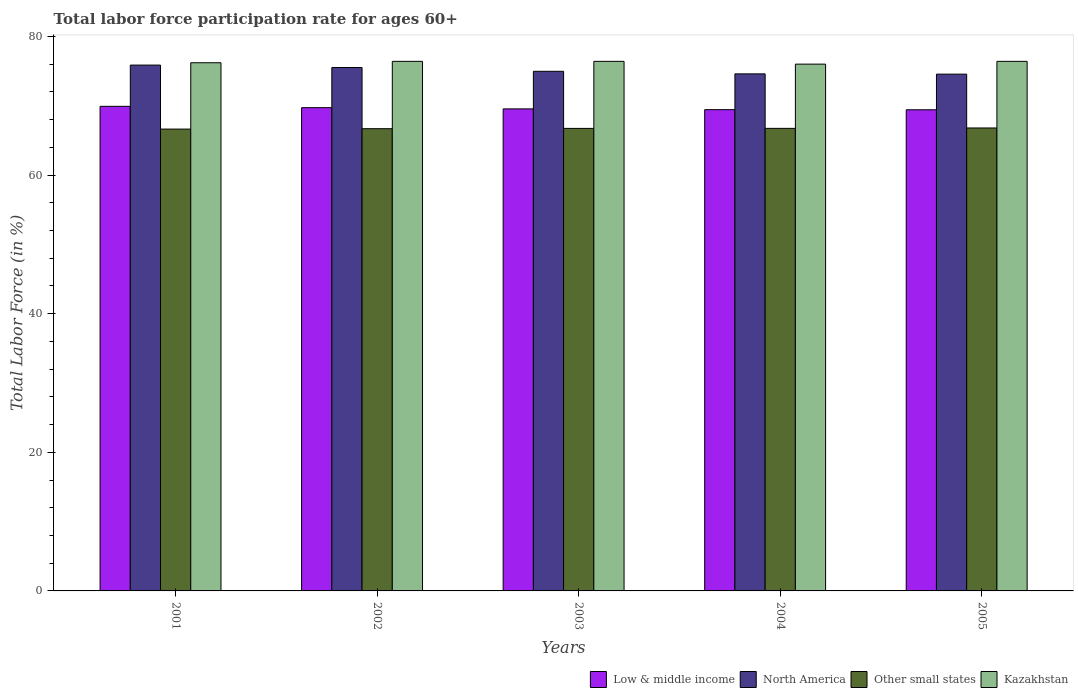How many different coloured bars are there?
Offer a very short reply. 4. How many groups of bars are there?
Offer a very short reply. 5. Are the number of bars per tick equal to the number of legend labels?
Provide a succinct answer. Yes. How many bars are there on the 5th tick from the left?
Give a very brief answer. 4. How many bars are there on the 3rd tick from the right?
Make the answer very short. 4. What is the labor force participation rate in Kazakhstan in 2001?
Offer a terse response. 76.2. Across all years, what is the maximum labor force participation rate in Low & middle income?
Ensure brevity in your answer.  69.91. Across all years, what is the minimum labor force participation rate in North America?
Your answer should be compact. 74.55. In which year was the labor force participation rate in North America maximum?
Provide a short and direct response. 2001. In which year was the labor force participation rate in Kazakhstan minimum?
Offer a very short reply. 2004. What is the total labor force participation rate in North America in the graph?
Keep it short and to the point. 375.48. What is the difference between the labor force participation rate in North America in 2004 and that in 2005?
Your answer should be compact. 0.04. What is the difference between the labor force participation rate in Kazakhstan in 2003 and the labor force participation rate in Other small states in 2001?
Give a very brief answer. 9.77. What is the average labor force participation rate in Other small states per year?
Your answer should be very brief. 66.71. In the year 2004, what is the difference between the labor force participation rate in North America and labor force participation rate in Kazakhstan?
Your response must be concise. -1.41. In how many years, is the labor force participation rate in Low & middle income greater than 44 %?
Make the answer very short. 5. What is the ratio of the labor force participation rate in Kazakhstan in 2001 to that in 2004?
Your answer should be compact. 1. What is the difference between the highest and the lowest labor force participation rate in Other small states?
Provide a succinct answer. 0.16. Is the sum of the labor force participation rate in Kazakhstan in 2001 and 2003 greater than the maximum labor force participation rate in Other small states across all years?
Give a very brief answer. Yes. What does the 4th bar from the right in 2001 represents?
Your answer should be very brief. Low & middle income. Is it the case that in every year, the sum of the labor force participation rate in North America and labor force participation rate in Kazakhstan is greater than the labor force participation rate in Other small states?
Offer a very short reply. Yes. Are all the bars in the graph horizontal?
Keep it short and to the point. No. How many years are there in the graph?
Make the answer very short. 5. What is the difference between two consecutive major ticks on the Y-axis?
Give a very brief answer. 20. Where does the legend appear in the graph?
Offer a terse response. Bottom right. How are the legend labels stacked?
Provide a short and direct response. Horizontal. What is the title of the graph?
Offer a very short reply. Total labor force participation rate for ages 60+. What is the label or title of the X-axis?
Provide a succinct answer. Years. What is the label or title of the Y-axis?
Your response must be concise. Total Labor Force (in %). What is the Total Labor Force (in %) of Low & middle income in 2001?
Ensure brevity in your answer.  69.91. What is the Total Labor Force (in %) in North America in 2001?
Keep it short and to the point. 75.86. What is the Total Labor Force (in %) in Other small states in 2001?
Your answer should be compact. 66.63. What is the Total Labor Force (in %) of Kazakhstan in 2001?
Offer a terse response. 76.2. What is the Total Labor Force (in %) of Low & middle income in 2002?
Your response must be concise. 69.72. What is the Total Labor Force (in %) of North America in 2002?
Make the answer very short. 75.51. What is the Total Labor Force (in %) in Other small states in 2002?
Ensure brevity in your answer.  66.69. What is the Total Labor Force (in %) in Kazakhstan in 2002?
Your response must be concise. 76.4. What is the Total Labor Force (in %) of Low & middle income in 2003?
Provide a succinct answer. 69.54. What is the Total Labor Force (in %) in North America in 2003?
Your answer should be very brief. 74.96. What is the Total Labor Force (in %) in Other small states in 2003?
Keep it short and to the point. 66.73. What is the Total Labor Force (in %) in Kazakhstan in 2003?
Keep it short and to the point. 76.4. What is the Total Labor Force (in %) of Low & middle income in 2004?
Offer a terse response. 69.43. What is the Total Labor Force (in %) in North America in 2004?
Offer a very short reply. 74.59. What is the Total Labor Force (in %) in Other small states in 2004?
Your response must be concise. 66.73. What is the Total Labor Force (in %) in Kazakhstan in 2004?
Your response must be concise. 76. What is the Total Labor Force (in %) of Low & middle income in 2005?
Keep it short and to the point. 69.41. What is the Total Labor Force (in %) of North America in 2005?
Your answer should be very brief. 74.55. What is the Total Labor Force (in %) in Other small states in 2005?
Provide a succinct answer. 66.79. What is the Total Labor Force (in %) of Kazakhstan in 2005?
Offer a terse response. 76.4. Across all years, what is the maximum Total Labor Force (in %) of Low & middle income?
Make the answer very short. 69.91. Across all years, what is the maximum Total Labor Force (in %) in North America?
Ensure brevity in your answer.  75.86. Across all years, what is the maximum Total Labor Force (in %) of Other small states?
Provide a short and direct response. 66.79. Across all years, what is the maximum Total Labor Force (in %) in Kazakhstan?
Ensure brevity in your answer.  76.4. Across all years, what is the minimum Total Labor Force (in %) of Low & middle income?
Offer a terse response. 69.41. Across all years, what is the minimum Total Labor Force (in %) in North America?
Make the answer very short. 74.55. Across all years, what is the minimum Total Labor Force (in %) of Other small states?
Your answer should be compact. 66.63. What is the total Total Labor Force (in %) in Low & middle income in the graph?
Your response must be concise. 348.01. What is the total Total Labor Force (in %) in North America in the graph?
Your response must be concise. 375.48. What is the total Total Labor Force (in %) of Other small states in the graph?
Your answer should be compact. 333.56. What is the total Total Labor Force (in %) in Kazakhstan in the graph?
Give a very brief answer. 381.4. What is the difference between the Total Labor Force (in %) in Low & middle income in 2001 and that in 2002?
Offer a terse response. 0.19. What is the difference between the Total Labor Force (in %) of North America in 2001 and that in 2002?
Make the answer very short. 0.35. What is the difference between the Total Labor Force (in %) in Other small states in 2001 and that in 2002?
Make the answer very short. -0.06. What is the difference between the Total Labor Force (in %) in Low & middle income in 2001 and that in 2003?
Make the answer very short. 0.37. What is the difference between the Total Labor Force (in %) in North America in 2001 and that in 2003?
Offer a very short reply. 0.9. What is the difference between the Total Labor Force (in %) in Other small states in 2001 and that in 2003?
Provide a short and direct response. -0.1. What is the difference between the Total Labor Force (in %) in Kazakhstan in 2001 and that in 2003?
Give a very brief answer. -0.2. What is the difference between the Total Labor Force (in %) of Low & middle income in 2001 and that in 2004?
Ensure brevity in your answer.  0.48. What is the difference between the Total Labor Force (in %) in North America in 2001 and that in 2004?
Ensure brevity in your answer.  1.27. What is the difference between the Total Labor Force (in %) in Other small states in 2001 and that in 2004?
Your answer should be very brief. -0.1. What is the difference between the Total Labor Force (in %) in Kazakhstan in 2001 and that in 2004?
Give a very brief answer. 0.2. What is the difference between the Total Labor Force (in %) in Low & middle income in 2001 and that in 2005?
Provide a succinct answer. 0.5. What is the difference between the Total Labor Force (in %) of North America in 2001 and that in 2005?
Provide a short and direct response. 1.31. What is the difference between the Total Labor Force (in %) of Other small states in 2001 and that in 2005?
Offer a very short reply. -0.16. What is the difference between the Total Labor Force (in %) of Kazakhstan in 2001 and that in 2005?
Offer a terse response. -0.2. What is the difference between the Total Labor Force (in %) in Low & middle income in 2002 and that in 2003?
Your response must be concise. 0.18. What is the difference between the Total Labor Force (in %) in North America in 2002 and that in 2003?
Make the answer very short. 0.55. What is the difference between the Total Labor Force (in %) in Other small states in 2002 and that in 2003?
Provide a short and direct response. -0.04. What is the difference between the Total Labor Force (in %) in Low & middle income in 2002 and that in 2004?
Ensure brevity in your answer.  0.29. What is the difference between the Total Labor Force (in %) in North America in 2002 and that in 2004?
Make the answer very short. 0.92. What is the difference between the Total Labor Force (in %) in Other small states in 2002 and that in 2004?
Make the answer very short. -0.05. What is the difference between the Total Labor Force (in %) of Kazakhstan in 2002 and that in 2004?
Offer a terse response. 0.4. What is the difference between the Total Labor Force (in %) of Low & middle income in 2002 and that in 2005?
Ensure brevity in your answer.  0.31. What is the difference between the Total Labor Force (in %) of North America in 2002 and that in 2005?
Keep it short and to the point. 0.96. What is the difference between the Total Labor Force (in %) in Other small states in 2002 and that in 2005?
Your response must be concise. -0.1. What is the difference between the Total Labor Force (in %) in Low & middle income in 2003 and that in 2004?
Give a very brief answer. 0.11. What is the difference between the Total Labor Force (in %) of North America in 2003 and that in 2004?
Your response must be concise. 0.37. What is the difference between the Total Labor Force (in %) of Other small states in 2003 and that in 2004?
Keep it short and to the point. -0. What is the difference between the Total Labor Force (in %) in Kazakhstan in 2003 and that in 2004?
Keep it short and to the point. 0.4. What is the difference between the Total Labor Force (in %) of Low & middle income in 2003 and that in 2005?
Offer a very short reply. 0.13. What is the difference between the Total Labor Force (in %) of North America in 2003 and that in 2005?
Ensure brevity in your answer.  0.41. What is the difference between the Total Labor Force (in %) in Other small states in 2003 and that in 2005?
Your answer should be very brief. -0.06. What is the difference between the Total Labor Force (in %) in Kazakhstan in 2003 and that in 2005?
Give a very brief answer. 0. What is the difference between the Total Labor Force (in %) in Low & middle income in 2004 and that in 2005?
Provide a short and direct response. 0.02. What is the difference between the Total Labor Force (in %) of North America in 2004 and that in 2005?
Keep it short and to the point. 0.04. What is the difference between the Total Labor Force (in %) of Other small states in 2004 and that in 2005?
Offer a terse response. -0.06. What is the difference between the Total Labor Force (in %) in Kazakhstan in 2004 and that in 2005?
Your response must be concise. -0.4. What is the difference between the Total Labor Force (in %) of Low & middle income in 2001 and the Total Labor Force (in %) of North America in 2002?
Your response must be concise. -5.6. What is the difference between the Total Labor Force (in %) in Low & middle income in 2001 and the Total Labor Force (in %) in Other small states in 2002?
Your answer should be compact. 3.22. What is the difference between the Total Labor Force (in %) of Low & middle income in 2001 and the Total Labor Force (in %) of Kazakhstan in 2002?
Your answer should be compact. -6.49. What is the difference between the Total Labor Force (in %) in North America in 2001 and the Total Labor Force (in %) in Other small states in 2002?
Keep it short and to the point. 9.18. What is the difference between the Total Labor Force (in %) of North America in 2001 and the Total Labor Force (in %) of Kazakhstan in 2002?
Provide a short and direct response. -0.54. What is the difference between the Total Labor Force (in %) in Other small states in 2001 and the Total Labor Force (in %) in Kazakhstan in 2002?
Your answer should be compact. -9.77. What is the difference between the Total Labor Force (in %) in Low & middle income in 2001 and the Total Labor Force (in %) in North America in 2003?
Your response must be concise. -5.05. What is the difference between the Total Labor Force (in %) in Low & middle income in 2001 and the Total Labor Force (in %) in Other small states in 2003?
Provide a succinct answer. 3.18. What is the difference between the Total Labor Force (in %) of Low & middle income in 2001 and the Total Labor Force (in %) of Kazakhstan in 2003?
Keep it short and to the point. -6.49. What is the difference between the Total Labor Force (in %) of North America in 2001 and the Total Labor Force (in %) of Other small states in 2003?
Offer a very short reply. 9.13. What is the difference between the Total Labor Force (in %) in North America in 2001 and the Total Labor Force (in %) in Kazakhstan in 2003?
Your answer should be very brief. -0.54. What is the difference between the Total Labor Force (in %) of Other small states in 2001 and the Total Labor Force (in %) of Kazakhstan in 2003?
Make the answer very short. -9.77. What is the difference between the Total Labor Force (in %) of Low & middle income in 2001 and the Total Labor Force (in %) of North America in 2004?
Provide a succinct answer. -4.68. What is the difference between the Total Labor Force (in %) of Low & middle income in 2001 and the Total Labor Force (in %) of Other small states in 2004?
Your answer should be very brief. 3.18. What is the difference between the Total Labor Force (in %) in Low & middle income in 2001 and the Total Labor Force (in %) in Kazakhstan in 2004?
Give a very brief answer. -6.09. What is the difference between the Total Labor Force (in %) in North America in 2001 and the Total Labor Force (in %) in Other small states in 2004?
Keep it short and to the point. 9.13. What is the difference between the Total Labor Force (in %) in North America in 2001 and the Total Labor Force (in %) in Kazakhstan in 2004?
Ensure brevity in your answer.  -0.14. What is the difference between the Total Labor Force (in %) of Other small states in 2001 and the Total Labor Force (in %) of Kazakhstan in 2004?
Your response must be concise. -9.37. What is the difference between the Total Labor Force (in %) of Low & middle income in 2001 and the Total Labor Force (in %) of North America in 2005?
Ensure brevity in your answer.  -4.64. What is the difference between the Total Labor Force (in %) of Low & middle income in 2001 and the Total Labor Force (in %) of Other small states in 2005?
Offer a very short reply. 3.12. What is the difference between the Total Labor Force (in %) of Low & middle income in 2001 and the Total Labor Force (in %) of Kazakhstan in 2005?
Keep it short and to the point. -6.49. What is the difference between the Total Labor Force (in %) of North America in 2001 and the Total Labor Force (in %) of Other small states in 2005?
Keep it short and to the point. 9.07. What is the difference between the Total Labor Force (in %) in North America in 2001 and the Total Labor Force (in %) in Kazakhstan in 2005?
Your response must be concise. -0.54. What is the difference between the Total Labor Force (in %) of Other small states in 2001 and the Total Labor Force (in %) of Kazakhstan in 2005?
Give a very brief answer. -9.77. What is the difference between the Total Labor Force (in %) of Low & middle income in 2002 and the Total Labor Force (in %) of North America in 2003?
Give a very brief answer. -5.24. What is the difference between the Total Labor Force (in %) of Low & middle income in 2002 and the Total Labor Force (in %) of Other small states in 2003?
Your response must be concise. 2.99. What is the difference between the Total Labor Force (in %) of Low & middle income in 2002 and the Total Labor Force (in %) of Kazakhstan in 2003?
Ensure brevity in your answer.  -6.68. What is the difference between the Total Labor Force (in %) of North America in 2002 and the Total Labor Force (in %) of Other small states in 2003?
Provide a succinct answer. 8.78. What is the difference between the Total Labor Force (in %) in North America in 2002 and the Total Labor Force (in %) in Kazakhstan in 2003?
Offer a terse response. -0.89. What is the difference between the Total Labor Force (in %) of Other small states in 2002 and the Total Labor Force (in %) of Kazakhstan in 2003?
Offer a very short reply. -9.71. What is the difference between the Total Labor Force (in %) in Low & middle income in 2002 and the Total Labor Force (in %) in North America in 2004?
Provide a succinct answer. -4.88. What is the difference between the Total Labor Force (in %) of Low & middle income in 2002 and the Total Labor Force (in %) of Other small states in 2004?
Your answer should be very brief. 2.99. What is the difference between the Total Labor Force (in %) of Low & middle income in 2002 and the Total Labor Force (in %) of Kazakhstan in 2004?
Your answer should be very brief. -6.28. What is the difference between the Total Labor Force (in %) of North America in 2002 and the Total Labor Force (in %) of Other small states in 2004?
Provide a short and direct response. 8.78. What is the difference between the Total Labor Force (in %) in North America in 2002 and the Total Labor Force (in %) in Kazakhstan in 2004?
Make the answer very short. -0.49. What is the difference between the Total Labor Force (in %) of Other small states in 2002 and the Total Labor Force (in %) of Kazakhstan in 2004?
Provide a succinct answer. -9.31. What is the difference between the Total Labor Force (in %) in Low & middle income in 2002 and the Total Labor Force (in %) in North America in 2005?
Ensure brevity in your answer.  -4.83. What is the difference between the Total Labor Force (in %) in Low & middle income in 2002 and the Total Labor Force (in %) in Other small states in 2005?
Your answer should be very brief. 2.93. What is the difference between the Total Labor Force (in %) of Low & middle income in 2002 and the Total Labor Force (in %) of Kazakhstan in 2005?
Ensure brevity in your answer.  -6.68. What is the difference between the Total Labor Force (in %) of North America in 2002 and the Total Labor Force (in %) of Other small states in 2005?
Your answer should be very brief. 8.72. What is the difference between the Total Labor Force (in %) of North America in 2002 and the Total Labor Force (in %) of Kazakhstan in 2005?
Make the answer very short. -0.89. What is the difference between the Total Labor Force (in %) of Other small states in 2002 and the Total Labor Force (in %) of Kazakhstan in 2005?
Provide a succinct answer. -9.71. What is the difference between the Total Labor Force (in %) of Low & middle income in 2003 and the Total Labor Force (in %) of North America in 2004?
Provide a succinct answer. -5.05. What is the difference between the Total Labor Force (in %) of Low & middle income in 2003 and the Total Labor Force (in %) of Other small states in 2004?
Your answer should be compact. 2.81. What is the difference between the Total Labor Force (in %) of Low & middle income in 2003 and the Total Labor Force (in %) of Kazakhstan in 2004?
Provide a short and direct response. -6.46. What is the difference between the Total Labor Force (in %) in North America in 2003 and the Total Labor Force (in %) in Other small states in 2004?
Provide a short and direct response. 8.23. What is the difference between the Total Labor Force (in %) of North America in 2003 and the Total Labor Force (in %) of Kazakhstan in 2004?
Provide a short and direct response. -1.04. What is the difference between the Total Labor Force (in %) in Other small states in 2003 and the Total Labor Force (in %) in Kazakhstan in 2004?
Your response must be concise. -9.27. What is the difference between the Total Labor Force (in %) in Low & middle income in 2003 and the Total Labor Force (in %) in North America in 2005?
Give a very brief answer. -5.01. What is the difference between the Total Labor Force (in %) in Low & middle income in 2003 and the Total Labor Force (in %) in Other small states in 2005?
Your response must be concise. 2.75. What is the difference between the Total Labor Force (in %) in Low & middle income in 2003 and the Total Labor Force (in %) in Kazakhstan in 2005?
Your answer should be compact. -6.86. What is the difference between the Total Labor Force (in %) of North America in 2003 and the Total Labor Force (in %) of Other small states in 2005?
Make the answer very short. 8.17. What is the difference between the Total Labor Force (in %) of North America in 2003 and the Total Labor Force (in %) of Kazakhstan in 2005?
Offer a terse response. -1.44. What is the difference between the Total Labor Force (in %) of Other small states in 2003 and the Total Labor Force (in %) of Kazakhstan in 2005?
Your answer should be very brief. -9.67. What is the difference between the Total Labor Force (in %) in Low & middle income in 2004 and the Total Labor Force (in %) in North America in 2005?
Provide a succinct answer. -5.12. What is the difference between the Total Labor Force (in %) in Low & middle income in 2004 and the Total Labor Force (in %) in Other small states in 2005?
Ensure brevity in your answer.  2.64. What is the difference between the Total Labor Force (in %) in Low & middle income in 2004 and the Total Labor Force (in %) in Kazakhstan in 2005?
Keep it short and to the point. -6.97. What is the difference between the Total Labor Force (in %) of North America in 2004 and the Total Labor Force (in %) of Other small states in 2005?
Keep it short and to the point. 7.8. What is the difference between the Total Labor Force (in %) in North America in 2004 and the Total Labor Force (in %) in Kazakhstan in 2005?
Your answer should be very brief. -1.81. What is the difference between the Total Labor Force (in %) in Other small states in 2004 and the Total Labor Force (in %) in Kazakhstan in 2005?
Give a very brief answer. -9.67. What is the average Total Labor Force (in %) in Low & middle income per year?
Give a very brief answer. 69.6. What is the average Total Labor Force (in %) of North America per year?
Your response must be concise. 75.1. What is the average Total Labor Force (in %) of Other small states per year?
Provide a short and direct response. 66.71. What is the average Total Labor Force (in %) in Kazakhstan per year?
Ensure brevity in your answer.  76.28. In the year 2001, what is the difference between the Total Labor Force (in %) in Low & middle income and Total Labor Force (in %) in North America?
Your response must be concise. -5.95. In the year 2001, what is the difference between the Total Labor Force (in %) in Low & middle income and Total Labor Force (in %) in Other small states?
Give a very brief answer. 3.28. In the year 2001, what is the difference between the Total Labor Force (in %) of Low & middle income and Total Labor Force (in %) of Kazakhstan?
Give a very brief answer. -6.29. In the year 2001, what is the difference between the Total Labor Force (in %) of North America and Total Labor Force (in %) of Other small states?
Make the answer very short. 9.23. In the year 2001, what is the difference between the Total Labor Force (in %) of North America and Total Labor Force (in %) of Kazakhstan?
Provide a short and direct response. -0.34. In the year 2001, what is the difference between the Total Labor Force (in %) in Other small states and Total Labor Force (in %) in Kazakhstan?
Make the answer very short. -9.57. In the year 2002, what is the difference between the Total Labor Force (in %) of Low & middle income and Total Labor Force (in %) of North America?
Keep it short and to the point. -5.79. In the year 2002, what is the difference between the Total Labor Force (in %) of Low & middle income and Total Labor Force (in %) of Other small states?
Ensure brevity in your answer.  3.03. In the year 2002, what is the difference between the Total Labor Force (in %) in Low & middle income and Total Labor Force (in %) in Kazakhstan?
Keep it short and to the point. -6.68. In the year 2002, what is the difference between the Total Labor Force (in %) in North America and Total Labor Force (in %) in Other small states?
Give a very brief answer. 8.83. In the year 2002, what is the difference between the Total Labor Force (in %) in North America and Total Labor Force (in %) in Kazakhstan?
Keep it short and to the point. -0.89. In the year 2002, what is the difference between the Total Labor Force (in %) of Other small states and Total Labor Force (in %) of Kazakhstan?
Provide a short and direct response. -9.71. In the year 2003, what is the difference between the Total Labor Force (in %) of Low & middle income and Total Labor Force (in %) of North America?
Your answer should be very brief. -5.42. In the year 2003, what is the difference between the Total Labor Force (in %) in Low & middle income and Total Labor Force (in %) in Other small states?
Offer a very short reply. 2.81. In the year 2003, what is the difference between the Total Labor Force (in %) of Low & middle income and Total Labor Force (in %) of Kazakhstan?
Provide a short and direct response. -6.86. In the year 2003, what is the difference between the Total Labor Force (in %) in North America and Total Labor Force (in %) in Other small states?
Your answer should be compact. 8.24. In the year 2003, what is the difference between the Total Labor Force (in %) in North America and Total Labor Force (in %) in Kazakhstan?
Provide a short and direct response. -1.44. In the year 2003, what is the difference between the Total Labor Force (in %) of Other small states and Total Labor Force (in %) of Kazakhstan?
Offer a terse response. -9.67. In the year 2004, what is the difference between the Total Labor Force (in %) of Low & middle income and Total Labor Force (in %) of North America?
Offer a terse response. -5.16. In the year 2004, what is the difference between the Total Labor Force (in %) in Low & middle income and Total Labor Force (in %) in Other small states?
Offer a very short reply. 2.7. In the year 2004, what is the difference between the Total Labor Force (in %) of Low & middle income and Total Labor Force (in %) of Kazakhstan?
Provide a succinct answer. -6.57. In the year 2004, what is the difference between the Total Labor Force (in %) of North America and Total Labor Force (in %) of Other small states?
Provide a short and direct response. 7.86. In the year 2004, what is the difference between the Total Labor Force (in %) in North America and Total Labor Force (in %) in Kazakhstan?
Provide a short and direct response. -1.41. In the year 2004, what is the difference between the Total Labor Force (in %) of Other small states and Total Labor Force (in %) of Kazakhstan?
Your answer should be compact. -9.27. In the year 2005, what is the difference between the Total Labor Force (in %) in Low & middle income and Total Labor Force (in %) in North America?
Provide a succinct answer. -5.14. In the year 2005, what is the difference between the Total Labor Force (in %) of Low & middle income and Total Labor Force (in %) of Other small states?
Give a very brief answer. 2.62. In the year 2005, what is the difference between the Total Labor Force (in %) of Low & middle income and Total Labor Force (in %) of Kazakhstan?
Give a very brief answer. -6.99. In the year 2005, what is the difference between the Total Labor Force (in %) of North America and Total Labor Force (in %) of Other small states?
Your answer should be compact. 7.76. In the year 2005, what is the difference between the Total Labor Force (in %) in North America and Total Labor Force (in %) in Kazakhstan?
Offer a very short reply. -1.85. In the year 2005, what is the difference between the Total Labor Force (in %) of Other small states and Total Labor Force (in %) of Kazakhstan?
Keep it short and to the point. -9.61. What is the ratio of the Total Labor Force (in %) of Kazakhstan in 2001 to that in 2002?
Keep it short and to the point. 1. What is the ratio of the Total Labor Force (in %) in Low & middle income in 2001 to that in 2003?
Ensure brevity in your answer.  1.01. What is the ratio of the Total Labor Force (in %) in Other small states in 2001 to that in 2003?
Offer a terse response. 1. What is the ratio of the Total Labor Force (in %) in Kazakhstan in 2001 to that in 2003?
Your answer should be compact. 1. What is the ratio of the Total Labor Force (in %) of Other small states in 2001 to that in 2004?
Provide a succinct answer. 1. What is the ratio of the Total Labor Force (in %) of Low & middle income in 2001 to that in 2005?
Offer a very short reply. 1.01. What is the ratio of the Total Labor Force (in %) in North America in 2001 to that in 2005?
Offer a very short reply. 1.02. What is the ratio of the Total Labor Force (in %) of Low & middle income in 2002 to that in 2003?
Your response must be concise. 1. What is the ratio of the Total Labor Force (in %) in North America in 2002 to that in 2003?
Provide a succinct answer. 1.01. What is the ratio of the Total Labor Force (in %) in Other small states in 2002 to that in 2003?
Your answer should be compact. 1. What is the ratio of the Total Labor Force (in %) in Low & middle income in 2002 to that in 2004?
Ensure brevity in your answer.  1. What is the ratio of the Total Labor Force (in %) in North America in 2002 to that in 2004?
Provide a succinct answer. 1.01. What is the ratio of the Total Labor Force (in %) of Other small states in 2002 to that in 2004?
Give a very brief answer. 1. What is the ratio of the Total Labor Force (in %) in North America in 2002 to that in 2005?
Your answer should be very brief. 1.01. What is the ratio of the Total Labor Force (in %) in Other small states in 2002 to that in 2005?
Offer a very short reply. 1. What is the ratio of the Total Labor Force (in %) in Kazakhstan in 2002 to that in 2005?
Give a very brief answer. 1. What is the ratio of the Total Labor Force (in %) in Other small states in 2003 to that in 2004?
Give a very brief answer. 1. What is the ratio of the Total Labor Force (in %) in Kazakhstan in 2003 to that in 2004?
Give a very brief answer. 1.01. What is the ratio of the Total Labor Force (in %) in Low & middle income in 2003 to that in 2005?
Make the answer very short. 1. What is the ratio of the Total Labor Force (in %) in Other small states in 2003 to that in 2005?
Make the answer very short. 1. What is the ratio of the Total Labor Force (in %) in Kazakhstan in 2003 to that in 2005?
Ensure brevity in your answer.  1. What is the ratio of the Total Labor Force (in %) of Low & middle income in 2004 to that in 2005?
Offer a terse response. 1. What is the difference between the highest and the second highest Total Labor Force (in %) of Low & middle income?
Your answer should be very brief. 0.19. What is the difference between the highest and the second highest Total Labor Force (in %) in North America?
Provide a short and direct response. 0.35. What is the difference between the highest and the second highest Total Labor Force (in %) of Other small states?
Keep it short and to the point. 0.06. What is the difference between the highest and the lowest Total Labor Force (in %) of Low & middle income?
Your response must be concise. 0.5. What is the difference between the highest and the lowest Total Labor Force (in %) of North America?
Keep it short and to the point. 1.31. What is the difference between the highest and the lowest Total Labor Force (in %) of Other small states?
Offer a terse response. 0.16. 